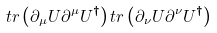<formula> <loc_0><loc_0><loc_500><loc_500>t r \left ( \partial _ { \mu } U \partial ^ { \mu } U ^ { \dagger } \right ) t r \left ( \partial _ { \nu } U \partial ^ { \nu } U ^ { \dagger } \right )</formula> 